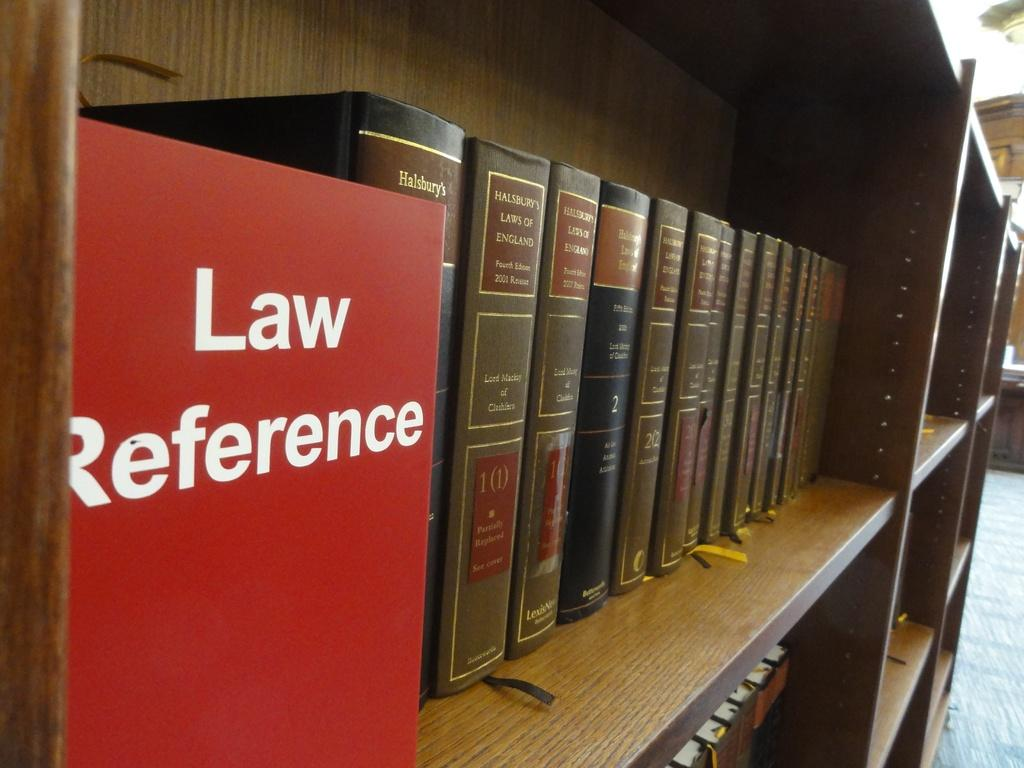Provide a one-sentence caption for the provided image. A library bookshelf with Law Reference books along the shelf. 